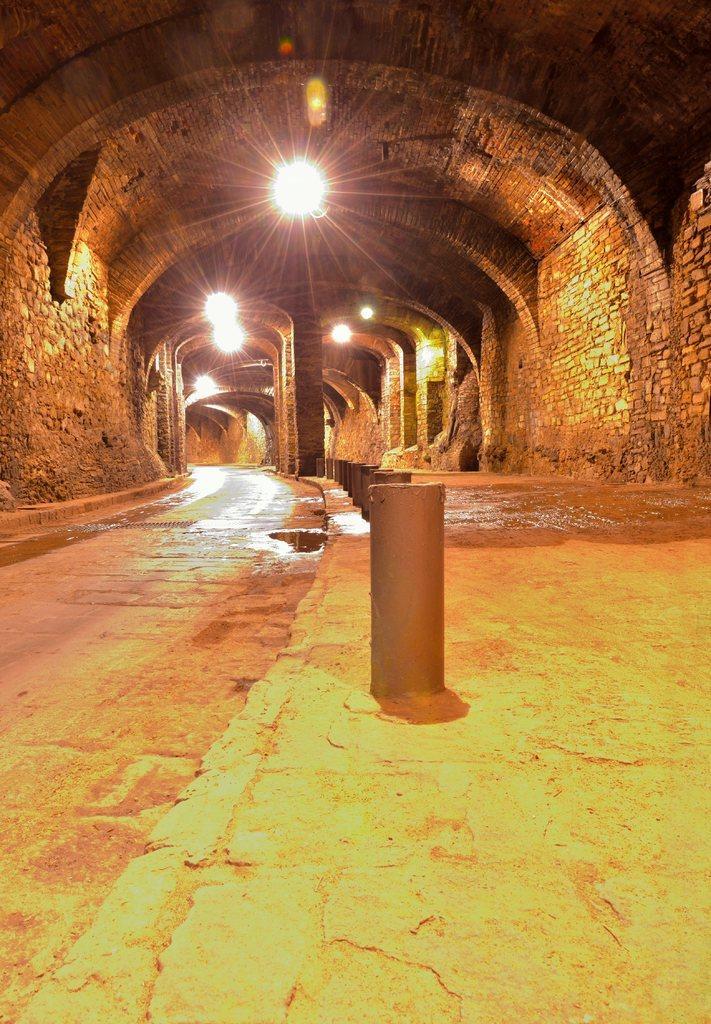How would you summarize this image in a sentence or two? In this image we can see one tunnel, some lights attached to the tunnel, some water on the ground, some pillars and some concrete poles on the ground. 